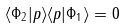Convert formula to latex. <formula><loc_0><loc_0><loc_500><loc_500>\langle \Phi _ { 2 } | p \rangle \langle p | \Phi _ { 1 } \rangle = 0</formula> 